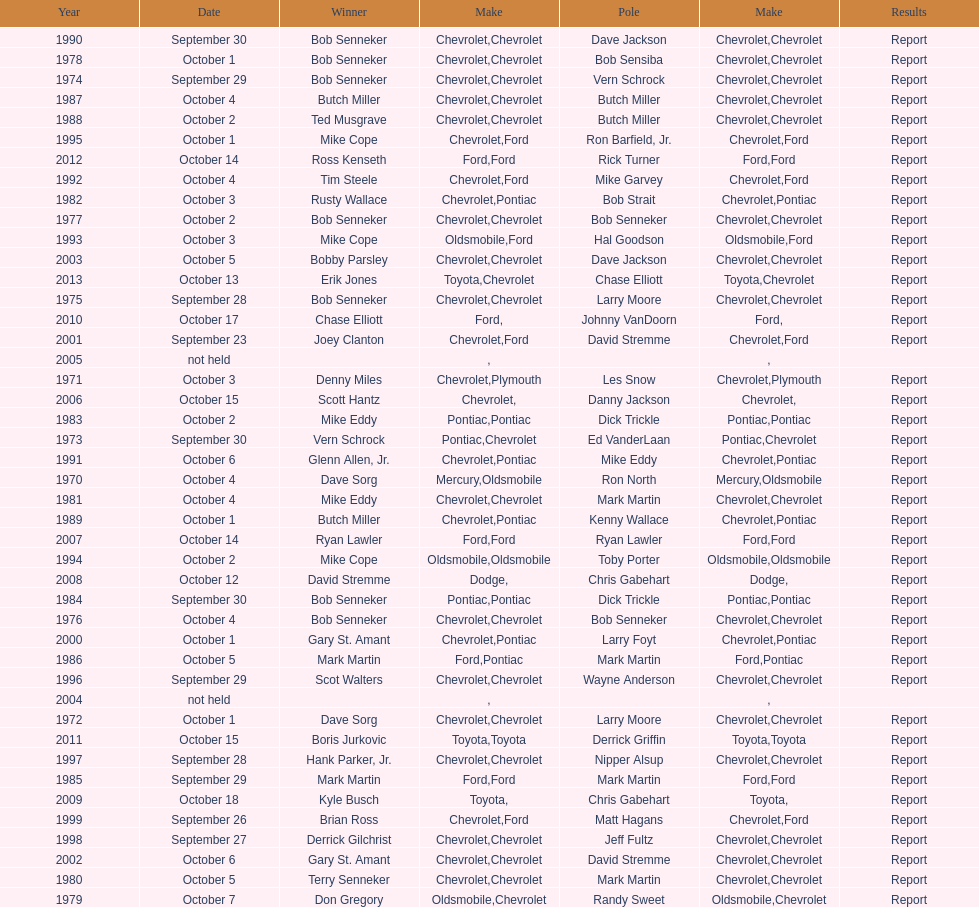Who on the lineup has the highest count of successive wins? Bob Senneker. 